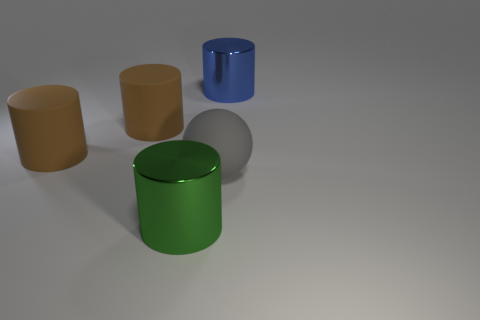What material is the cylinder that is to the right of the metal cylinder that is on the left side of the blue metallic thing?
Your answer should be compact. Metal. What is the size of the shiny object to the right of the thing that is in front of the large rubber object that is right of the green cylinder?
Make the answer very short. Large. Does the gray matte sphere have the same size as the blue metallic thing?
Your answer should be compact. Yes. Is the shape of the big metal thing in front of the large blue cylinder the same as the metallic object behind the gray sphere?
Give a very brief answer. Yes. Are there any rubber spheres that are in front of the metallic thing left of the large blue metallic cylinder?
Keep it short and to the point. No. Is there a green shiny cube?
Your answer should be very brief. No. How many gray matte cylinders have the same size as the rubber ball?
Offer a terse response. 0. How many objects are right of the big green object and in front of the large blue cylinder?
Keep it short and to the point. 1. Is the size of the metal cylinder that is in front of the blue cylinder the same as the large blue shiny object?
Your response must be concise. Yes. Is there a big cylinder of the same color as the rubber sphere?
Offer a terse response. No. 